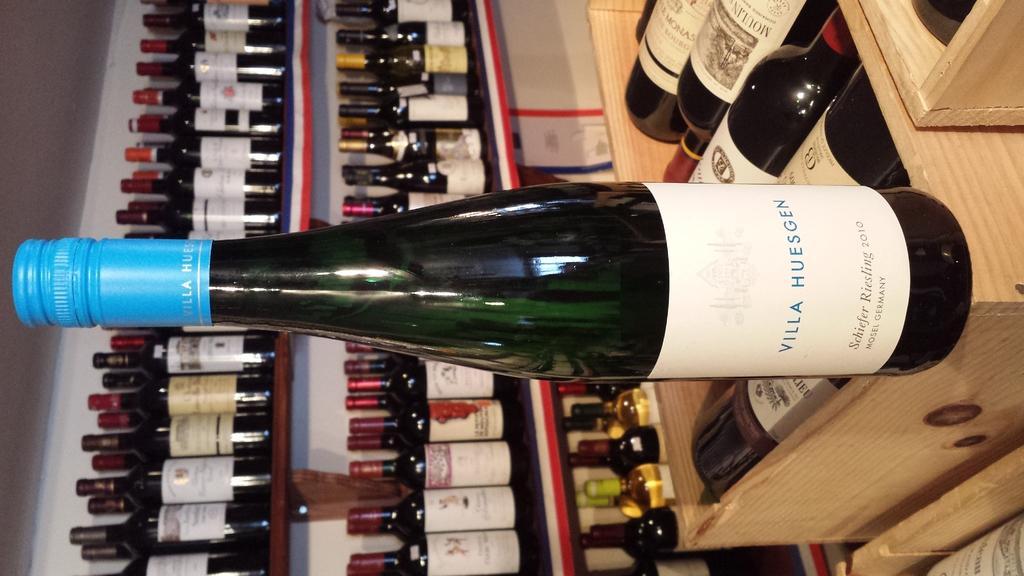Could you give a brief overview of what you see in this image? In the picture I can see an alcohol bottle in the middle of the picture. I can see the alcohol bottles in the wooden stock boxes. I can see the alcohol bottles on the wooden shelves on the left side. 